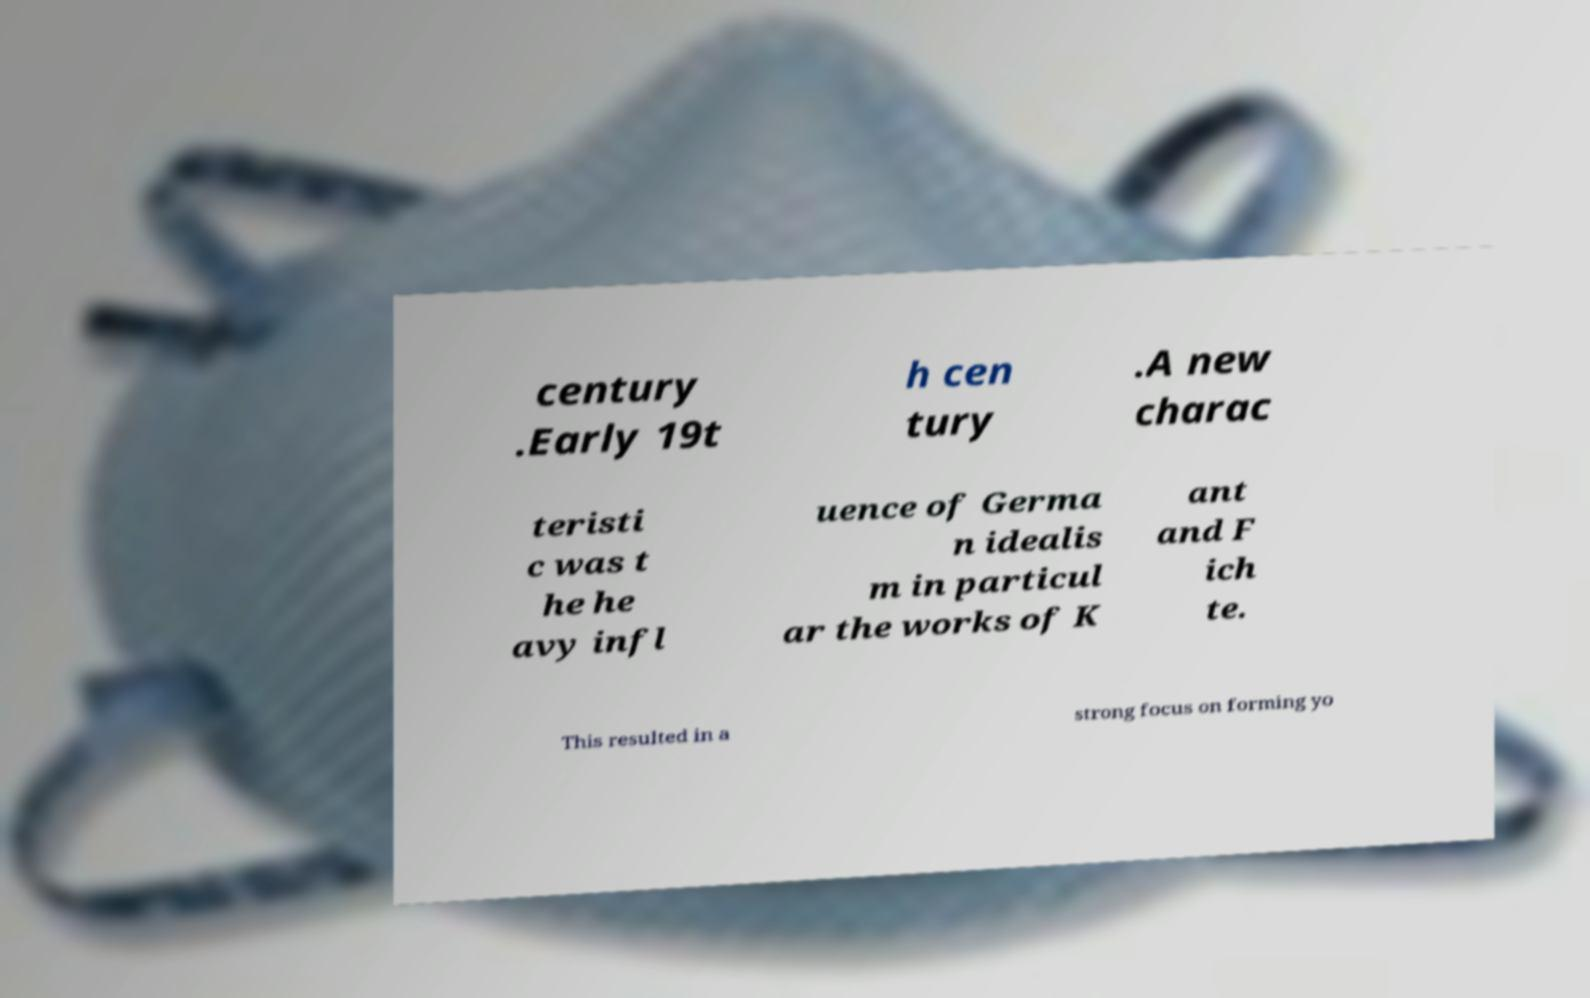Please identify and transcribe the text found in this image. century .Early 19t h cen tury .A new charac teristi c was t he he avy infl uence of Germa n idealis m in particul ar the works of K ant and F ich te. This resulted in a strong focus on forming yo 